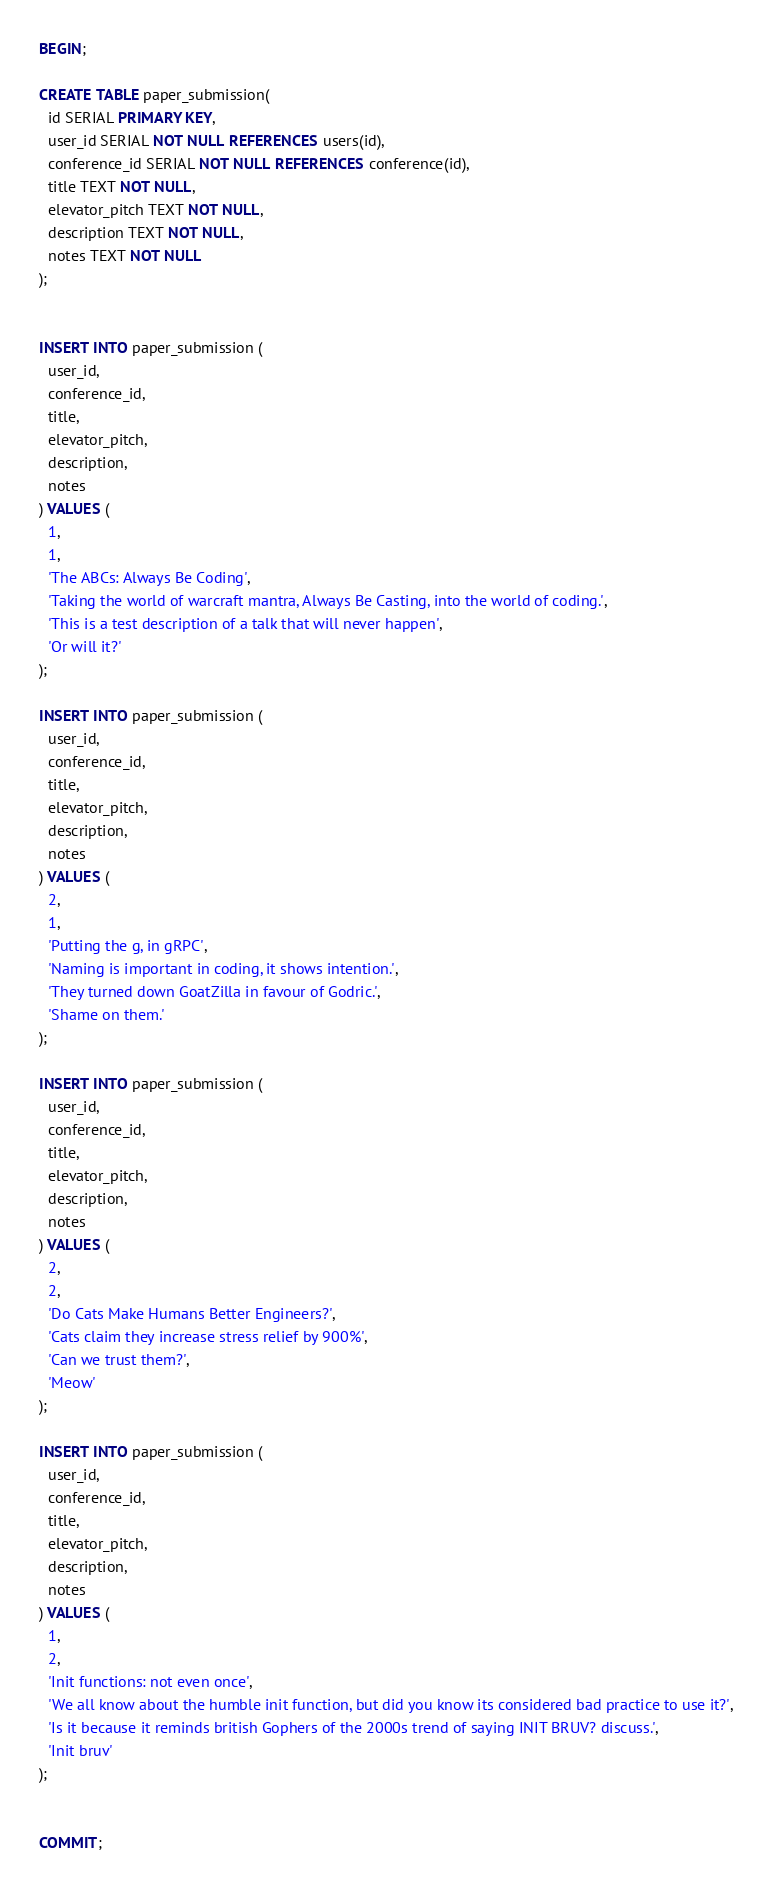Convert code to text. <code><loc_0><loc_0><loc_500><loc_500><_SQL_>BEGIN;

CREATE TABLE paper_submission(
  id SERIAL PRIMARY KEY,
  user_id SERIAL NOT NULL REFERENCES users(id),
  conference_id SERIAL NOT NULL REFERENCES conference(id),
  title TEXT NOT NULL,
  elevator_pitch TEXT NOT NULL,
  description TEXT NOT NULL,
  notes TEXT NOT NULL
);


INSERT INTO paper_submission (
  user_id,
  conference_id,
  title,
  elevator_pitch,
  description,
  notes
) VALUES (
  1,
  1,
  'The ABCs: Always Be Coding',
  'Taking the world of warcraft mantra, Always Be Casting, into the world of coding.',
  'This is a test description of a talk that will never happen',
  'Or will it?'
);

INSERT INTO paper_submission (
  user_id,
  conference_id,
  title,
  elevator_pitch,
  description,
  notes
) VALUES (
  2,
  1,
  'Putting the g, in gRPC',
  'Naming is important in coding, it shows intention.',
  'They turned down GoatZilla in favour of Godric.',
  'Shame on them.'
);

INSERT INTO paper_submission (
  user_id,
  conference_id,
  title,
  elevator_pitch,
  description,
  notes
) VALUES (
  2,
  2,
  'Do Cats Make Humans Better Engineers?',
  'Cats claim they increase stress relief by 900%',
  'Can we trust them?',
  'Meow'
);

INSERT INTO paper_submission (
  user_id,
  conference_id,
  title,
  elevator_pitch,
  description,
  notes
) VALUES (
  1,
  2,
  'Init functions: not even once',
  'We all know about the humble init function, but did you know its considered bad practice to use it?',
  'Is it because it reminds british Gophers of the 2000s trend of saying INIT BRUV? discuss.',
  'Init bruv'
);


COMMIT;</code> 